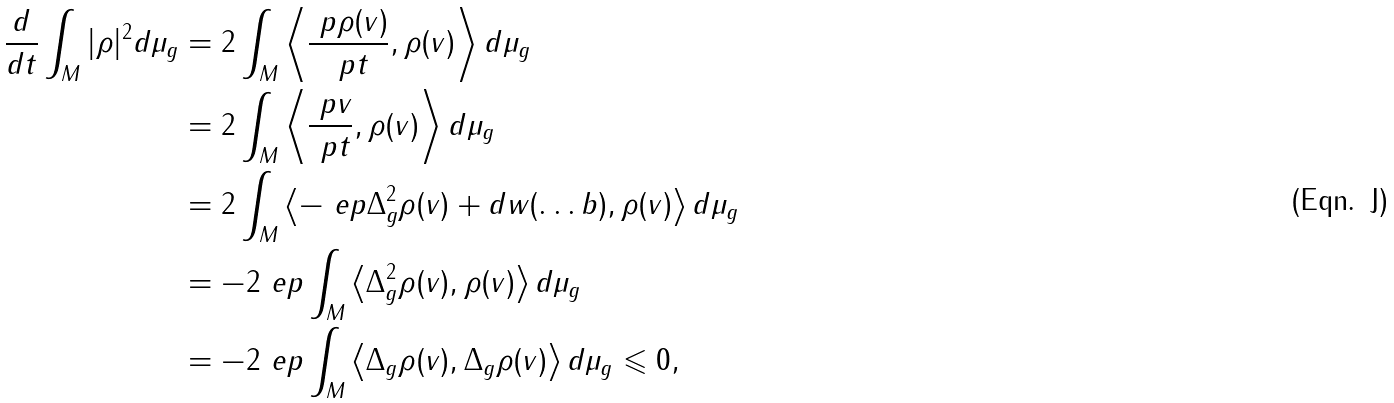<formula> <loc_0><loc_0><loc_500><loc_500>\frac { d } { d t } \int _ { M } | \rho | ^ { 2 } d \mu _ { g } & = 2 \int _ { M } \left \langle \frac { \ p { \rho ( v ) } } { \ p { t } } , \rho ( v ) \right \rangle d \mu _ { g } \\ & = 2 \int _ { M } \left \langle \frac { \ p { v } } { \ p { t } } , \rho ( v ) \right \rangle d \mu _ { g } \\ & = 2 \int _ { M } \left \langle - \ e p \Delta _ { g } ^ { 2 } \rho ( v ) + d w ( \dots b ) , \rho ( v ) \right \rangle d \mu _ { g } \\ & = - 2 \ e p \int _ { M } \left \langle \Delta _ { g } ^ { 2 } \rho ( v ) , \rho ( v ) \right \rangle d \mu _ { g } \\ & = - 2 \ e p \int _ { M } \left \langle \Delta _ { g } \rho ( v ) , \Delta _ { g } \rho ( v ) \right \rangle d \mu _ { g } \leqslant 0 ,</formula> 